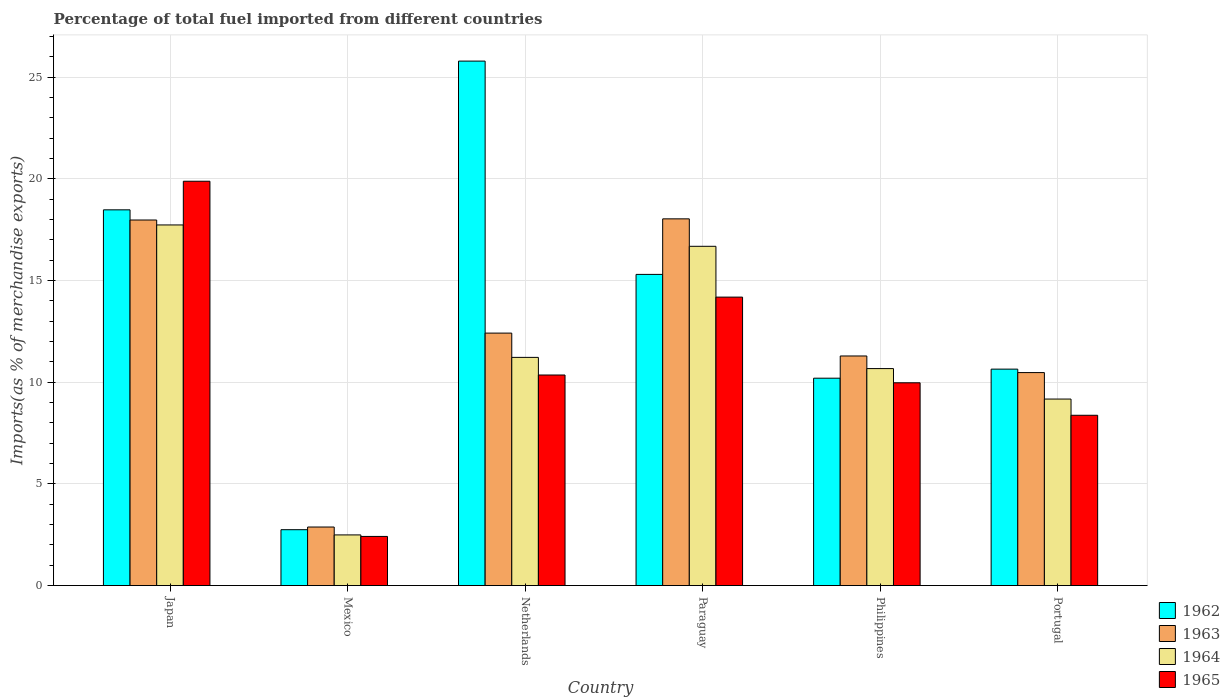How many different coloured bars are there?
Give a very brief answer. 4. How many groups of bars are there?
Keep it short and to the point. 6. Are the number of bars per tick equal to the number of legend labels?
Provide a short and direct response. Yes. How many bars are there on the 3rd tick from the left?
Offer a terse response. 4. What is the label of the 4th group of bars from the left?
Offer a terse response. Paraguay. In how many cases, is the number of bars for a given country not equal to the number of legend labels?
Provide a succinct answer. 0. What is the percentage of imports to different countries in 1963 in Portugal?
Offer a terse response. 10.47. Across all countries, what is the maximum percentage of imports to different countries in 1962?
Make the answer very short. 25.79. Across all countries, what is the minimum percentage of imports to different countries in 1965?
Your answer should be compact. 2.42. In which country was the percentage of imports to different countries in 1965 minimum?
Your answer should be compact. Mexico. What is the total percentage of imports to different countries in 1964 in the graph?
Your answer should be very brief. 67.96. What is the difference between the percentage of imports to different countries in 1964 in Paraguay and that in Philippines?
Provide a succinct answer. 6.01. What is the difference between the percentage of imports to different countries in 1964 in Paraguay and the percentage of imports to different countries in 1963 in Netherlands?
Make the answer very short. 4.27. What is the average percentage of imports to different countries in 1965 per country?
Keep it short and to the point. 10.86. What is the difference between the percentage of imports to different countries of/in 1964 and percentage of imports to different countries of/in 1965 in Philippines?
Your answer should be compact. 0.7. What is the ratio of the percentage of imports to different countries in 1963 in Mexico to that in Netherlands?
Make the answer very short. 0.23. Is the difference between the percentage of imports to different countries in 1964 in Paraguay and Philippines greater than the difference between the percentage of imports to different countries in 1965 in Paraguay and Philippines?
Offer a terse response. Yes. What is the difference between the highest and the second highest percentage of imports to different countries in 1963?
Offer a very short reply. -0.06. What is the difference between the highest and the lowest percentage of imports to different countries in 1965?
Ensure brevity in your answer.  17.46. Is the sum of the percentage of imports to different countries in 1965 in Japan and Paraguay greater than the maximum percentage of imports to different countries in 1962 across all countries?
Provide a succinct answer. Yes. Is it the case that in every country, the sum of the percentage of imports to different countries in 1962 and percentage of imports to different countries in 1965 is greater than the sum of percentage of imports to different countries in 1964 and percentage of imports to different countries in 1963?
Provide a succinct answer. No. What does the 4th bar from the left in Philippines represents?
Offer a very short reply. 1965. What does the 4th bar from the right in Netherlands represents?
Your response must be concise. 1962. Are all the bars in the graph horizontal?
Offer a terse response. No. Does the graph contain any zero values?
Ensure brevity in your answer.  No. Does the graph contain grids?
Give a very brief answer. Yes. How many legend labels are there?
Your response must be concise. 4. What is the title of the graph?
Make the answer very short. Percentage of total fuel imported from different countries. Does "1978" appear as one of the legend labels in the graph?
Provide a short and direct response. No. What is the label or title of the X-axis?
Provide a succinct answer. Country. What is the label or title of the Y-axis?
Provide a succinct answer. Imports(as % of merchandise exports). What is the Imports(as % of merchandise exports) in 1962 in Japan?
Ensure brevity in your answer.  18.47. What is the Imports(as % of merchandise exports) of 1963 in Japan?
Your answer should be compact. 17.97. What is the Imports(as % of merchandise exports) of 1964 in Japan?
Your answer should be very brief. 17.73. What is the Imports(as % of merchandise exports) in 1965 in Japan?
Provide a succinct answer. 19.88. What is the Imports(as % of merchandise exports) in 1962 in Mexico?
Provide a short and direct response. 2.75. What is the Imports(as % of merchandise exports) in 1963 in Mexico?
Provide a succinct answer. 2.88. What is the Imports(as % of merchandise exports) of 1964 in Mexico?
Your answer should be compact. 2.49. What is the Imports(as % of merchandise exports) of 1965 in Mexico?
Ensure brevity in your answer.  2.42. What is the Imports(as % of merchandise exports) of 1962 in Netherlands?
Keep it short and to the point. 25.79. What is the Imports(as % of merchandise exports) of 1963 in Netherlands?
Your answer should be compact. 12.41. What is the Imports(as % of merchandise exports) of 1964 in Netherlands?
Your answer should be compact. 11.22. What is the Imports(as % of merchandise exports) in 1965 in Netherlands?
Ensure brevity in your answer.  10.35. What is the Imports(as % of merchandise exports) in 1962 in Paraguay?
Provide a short and direct response. 15.3. What is the Imports(as % of merchandise exports) in 1963 in Paraguay?
Your answer should be compact. 18.03. What is the Imports(as % of merchandise exports) in 1964 in Paraguay?
Ensure brevity in your answer.  16.68. What is the Imports(as % of merchandise exports) of 1965 in Paraguay?
Keep it short and to the point. 14.18. What is the Imports(as % of merchandise exports) of 1962 in Philippines?
Ensure brevity in your answer.  10.2. What is the Imports(as % of merchandise exports) in 1963 in Philippines?
Your answer should be compact. 11.29. What is the Imports(as % of merchandise exports) of 1964 in Philippines?
Your response must be concise. 10.67. What is the Imports(as % of merchandise exports) of 1965 in Philippines?
Your answer should be compact. 9.97. What is the Imports(as % of merchandise exports) of 1962 in Portugal?
Your response must be concise. 10.64. What is the Imports(as % of merchandise exports) in 1963 in Portugal?
Offer a terse response. 10.47. What is the Imports(as % of merchandise exports) of 1964 in Portugal?
Provide a short and direct response. 9.17. What is the Imports(as % of merchandise exports) of 1965 in Portugal?
Give a very brief answer. 8.37. Across all countries, what is the maximum Imports(as % of merchandise exports) of 1962?
Offer a very short reply. 25.79. Across all countries, what is the maximum Imports(as % of merchandise exports) of 1963?
Provide a short and direct response. 18.03. Across all countries, what is the maximum Imports(as % of merchandise exports) in 1964?
Make the answer very short. 17.73. Across all countries, what is the maximum Imports(as % of merchandise exports) in 1965?
Offer a very short reply. 19.88. Across all countries, what is the minimum Imports(as % of merchandise exports) of 1962?
Offer a very short reply. 2.75. Across all countries, what is the minimum Imports(as % of merchandise exports) in 1963?
Ensure brevity in your answer.  2.88. Across all countries, what is the minimum Imports(as % of merchandise exports) in 1964?
Keep it short and to the point. 2.49. Across all countries, what is the minimum Imports(as % of merchandise exports) in 1965?
Offer a very short reply. 2.42. What is the total Imports(as % of merchandise exports) in 1962 in the graph?
Provide a short and direct response. 83.15. What is the total Imports(as % of merchandise exports) of 1963 in the graph?
Offer a terse response. 73.06. What is the total Imports(as % of merchandise exports) in 1964 in the graph?
Keep it short and to the point. 67.96. What is the total Imports(as % of merchandise exports) in 1965 in the graph?
Keep it short and to the point. 65.17. What is the difference between the Imports(as % of merchandise exports) of 1962 in Japan and that in Mexico?
Make the answer very short. 15.73. What is the difference between the Imports(as % of merchandise exports) in 1963 in Japan and that in Mexico?
Ensure brevity in your answer.  15.1. What is the difference between the Imports(as % of merchandise exports) of 1964 in Japan and that in Mexico?
Your answer should be very brief. 15.24. What is the difference between the Imports(as % of merchandise exports) of 1965 in Japan and that in Mexico?
Ensure brevity in your answer.  17.46. What is the difference between the Imports(as % of merchandise exports) in 1962 in Japan and that in Netherlands?
Your answer should be compact. -7.31. What is the difference between the Imports(as % of merchandise exports) of 1963 in Japan and that in Netherlands?
Make the answer very short. 5.56. What is the difference between the Imports(as % of merchandise exports) in 1964 in Japan and that in Netherlands?
Give a very brief answer. 6.51. What is the difference between the Imports(as % of merchandise exports) of 1965 in Japan and that in Netherlands?
Provide a succinct answer. 9.53. What is the difference between the Imports(as % of merchandise exports) of 1962 in Japan and that in Paraguay?
Make the answer very short. 3.17. What is the difference between the Imports(as % of merchandise exports) in 1963 in Japan and that in Paraguay?
Your answer should be compact. -0.06. What is the difference between the Imports(as % of merchandise exports) in 1964 in Japan and that in Paraguay?
Provide a succinct answer. 1.05. What is the difference between the Imports(as % of merchandise exports) of 1965 in Japan and that in Paraguay?
Your answer should be very brief. 5.7. What is the difference between the Imports(as % of merchandise exports) of 1962 in Japan and that in Philippines?
Offer a very short reply. 8.28. What is the difference between the Imports(as % of merchandise exports) of 1963 in Japan and that in Philippines?
Provide a succinct answer. 6.69. What is the difference between the Imports(as % of merchandise exports) of 1964 in Japan and that in Philippines?
Provide a succinct answer. 7.06. What is the difference between the Imports(as % of merchandise exports) of 1965 in Japan and that in Philippines?
Make the answer very short. 9.91. What is the difference between the Imports(as % of merchandise exports) in 1962 in Japan and that in Portugal?
Give a very brief answer. 7.83. What is the difference between the Imports(as % of merchandise exports) of 1963 in Japan and that in Portugal?
Keep it short and to the point. 7.5. What is the difference between the Imports(as % of merchandise exports) of 1964 in Japan and that in Portugal?
Provide a short and direct response. 8.56. What is the difference between the Imports(as % of merchandise exports) in 1965 in Japan and that in Portugal?
Ensure brevity in your answer.  11.51. What is the difference between the Imports(as % of merchandise exports) of 1962 in Mexico and that in Netherlands?
Your answer should be compact. -23.04. What is the difference between the Imports(as % of merchandise exports) of 1963 in Mexico and that in Netherlands?
Your answer should be compact. -9.53. What is the difference between the Imports(as % of merchandise exports) of 1964 in Mexico and that in Netherlands?
Provide a short and direct response. -8.73. What is the difference between the Imports(as % of merchandise exports) in 1965 in Mexico and that in Netherlands?
Offer a very short reply. -7.94. What is the difference between the Imports(as % of merchandise exports) in 1962 in Mexico and that in Paraguay?
Make the answer very short. -12.55. What is the difference between the Imports(as % of merchandise exports) of 1963 in Mexico and that in Paraguay?
Make the answer very short. -15.15. What is the difference between the Imports(as % of merchandise exports) in 1964 in Mexico and that in Paraguay?
Ensure brevity in your answer.  -14.19. What is the difference between the Imports(as % of merchandise exports) of 1965 in Mexico and that in Paraguay?
Provide a short and direct response. -11.77. What is the difference between the Imports(as % of merchandise exports) in 1962 in Mexico and that in Philippines?
Give a very brief answer. -7.45. What is the difference between the Imports(as % of merchandise exports) in 1963 in Mexico and that in Philippines?
Offer a very short reply. -8.41. What is the difference between the Imports(as % of merchandise exports) in 1964 in Mexico and that in Philippines?
Offer a terse response. -8.18. What is the difference between the Imports(as % of merchandise exports) of 1965 in Mexico and that in Philippines?
Give a very brief answer. -7.55. What is the difference between the Imports(as % of merchandise exports) in 1962 in Mexico and that in Portugal?
Offer a very short reply. -7.89. What is the difference between the Imports(as % of merchandise exports) of 1963 in Mexico and that in Portugal?
Your answer should be compact. -7.59. What is the difference between the Imports(as % of merchandise exports) of 1964 in Mexico and that in Portugal?
Make the answer very short. -6.68. What is the difference between the Imports(as % of merchandise exports) in 1965 in Mexico and that in Portugal?
Your answer should be compact. -5.96. What is the difference between the Imports(as % of merchandise exports) of 1962 in Netherlands and that in Paraguay?
Offer a terse response. 10.49. What is the difference between the Imports(as % of merchandise exports) in 1963 in Netherlands and that in Paraguay?
Make the answer very short. -5.62. What is the difference between the Imports(as % of merchandise exports) of 1964 in Netherlands and that in Paraguay?
Ensure brevity in your answer.  -5.46. What is the difference between the Imports(as % of merchandise exports) in 1965 in Netherlands and that in Paraguay?
Make the answer very short. -3.83. What is the difference between the Imports(as % of merchandise exports) in 1962 in Netherlands and that in Philippines?
Provide a short and direct response. 15.59. What is the difference between the Imports(as % of merchandise exports) of 1963 in Netherlands and that in Philippines?
Ensure brevity in your answer.  1.12. What is the difference between the Imports(as % of merchandise exports) in 1964 in Netherlands and that in Philippines?
Offer a terse response. 0.55. What is the difference between the Imports(as % of merchandise exports) in 1965 in Netherlands and that in Philippines?
Keep it short and to the point. 0.38. What is the difference between the Imports(as % of merchandise exports) in 1962 in Netherlands and that in Portugal?
Offer a very short reply. 15.15. What is the difference between the Imports(as % of merchandise exports) of 1963 in Netherlands and that in Portugal?
Offer a very short reply. 1.94. What is the difference between the Imports(as % of merchandise exports) in 1964 in Netherlands and that in Portugal?
Make the answer very short. 2.05. What is the difference between the Imports(as % of merchandise exports) in 1965 in Netherlands and that in Portugal?
Your response must be concise. 1.98. What is the difference between the Imports(as % of merchandise exports) of 1962 in Paraguay and that in Philippines?
Provide a short and direct response. 5.1. What is the difference between the Imports(as % of merchandise exports) in 1963 in Paraguay and that in Philippines?
Your answer should be compact. 6.74. What is the difference between the Imports(as % of merchandise exports) of 1964 in Paraguay and that in Philippines?
Make the answer very short. 6.01. What is the difference between the Imports(as % of merchandise exports) of 1965 in Paraguay and that in Philippines?
Offer a very short reply. 4.21. What is the difference between the Imports(as % of merchandise exports) in 1962 in Paraguay and that in Portugal?
Offer a terse response. 4.66. What is the difference between the Imports(as % of merchandise exports) of 1963 in Paraguay and that in Portugal?
Your answer should be very brief. 7.56. What is the difference between the Imports(as % of merchandise exports) of 1964 in Paraguay and that in Portugal?
Offer a very short reply. 7.51. What is the difference between the Imports(as % of merchandise exports) of 1965 in Paraguay and that in Portugal?
Provide a succinct answer. 5.81. What is the difference between the Imports(as % of merchandise exports) in 1962 in Philippines and that in Portugal?
Provide a succinct answer. -0.45. What is the difference between the Imports(as % of merchandise exports) in 1963 in Philippines and that in Portugal?
Offer a terse response. 0.82. What is the difference between the Imports(as % of merchandise exports) of 1964 in Philippines and that in Portugal?
Keep it short and to the point. 1.5. What is the difference between the Imports(as % of merchandise exports) of 1965 in Philippines and that in Portugal?
Offer a very short reply. 1.6. What is the difference between the Imports(as % of merchandise exports) of 1962 in Japan and the Imports(as % of merchandise exports) of 1963 in Mexico?
Your response must be concise. 15.6. What is the difference between the Imports(as % of merchandise exports) of 1962 in Japan and the Imports(as % of merchandise exports) of 1964 in Mexico?
Give a very brief answer. 15.98. What is the difference between the Imports(as % of merchandise exports) in 1962 in Japan and the Imports(as % of merchandise exports) in 1965 in Mexico?
Provide a succinct answer. 16.06. What is the difference between the Imports(as % of merchandise exports) of 1963 in Japan and the Imports(as % of merchandise exports) of 1964 in Mexico?
Provide a short and direct response. 15.48. What is the difference between the Imports(as % of merchandise exports) of 1963 in Japan and the Imports(as % of merchandise exports) of 1965 in Mexico?
Give a very brief answer. 15.56. What is the difference between the Imports(as % of merchandise exports) of 1964 in Japan and the Imports(as % of merchandise exports) of 1965 in Mexico?
Your answer should be compact. 15.32. What is the difference between the Imports(as % of merchandise exports) in 1962 in Japan and the Imports(as % of merchandise exports) in 1963 in Netherlands?
Your answer should be compact. 6.06. What is the difference between the Imports(as % of merchandise exports) of 1962 in Japan and the Imports(as % of merchandise exports) of 1964 in Netherlands?
Offer a very short reply. 7.25. What is the difference between the Imports(as % of merchandise exports) of 1962 in Japan and the Imports(as % of merchandise exports) of 1965 in Netherlands?
Your response must be concise. 8.12. What is the difference between the Imports(as % of merchandise exports) of 1963 in Japan and the Imports(as % of merchandise exports) of 1964 in Netherlands?
Ensure brevity in your answer.  6.76. What is the difference between the Imports(as % of merchandise exports) in 1963 in Japan and the Imports(as % of merchandise exports) in 1965 in Netherlands?
Offer a very short reply. 7.62. What is the difference between the Imports(as % of merchandise exports) in 1964 in Japan and the Imports(as % of merchandise exports) in 1965 in Netherlands?
Make the answer very short. 7.38. What is the difference between the Imports(as % of merchandise exports) in 1962 in Japan and the Imports(as % of merchandise exports) in 1963 in Paraguay?
Your answer should be compact. 0.44. What is the difference between the Imports(as % of merchandise exports) of 1962 in Japan and the Imports(as % of merchandise exports) of 1964 in Paraguay?
Provide a succinct answer. 1.79. What is the difference between the Imports(as % of merchandise exports) of 1962 in Japan and the Imports(as % of merchandise exports) of 1965 in Paraguay?
Your response must be concise. 4.29. What is the difference between the Imports(as % of merchandise exports) of 1963 in Japan and the Imports(as % of merchandise exports) of 1964 in Paraguay?
Offer a very short reply. 1.29. What is the difference between the Imports(as % of merchandise exports) of 1963 in Japan and the Imports(as % of merchandise exports) of 1965 in Paraguay?
Give a very brief answer. 3.79. What is the difference between the Imports(as % of merchandise exports) in 1964 in Japan and the Imports(as % of merchandise exports) in 1965 in Paraguay?
Your answer should be very brief. 3.55. What is the difference between the Imports(as % of merchandise exports) of 1962 in Japan and the Imports(as % of merchandise exports) of 1963 in Philippines?
Give a very brief answer. 7.19. What is the difference between the Imports(as % of merchandise exports) of 1962 in Japan and the Imports(as % of merchandise exports) of 1964 in Philippines?
Offer a very short reply. 7.81. What is the difference between the Imports(as % of merchandise exports) in 1962 in Japan and the Imports(as % of merchandise exports) in 1965 in Philippines?
Keep it short and to the point. 8.5. What is the difference between the Imports(as % of merchandise exports) of 1963 in Japan and the Imports(as % of merchandise exports) of 1964 in Philippines?
Ensure brevity in your answer.  7.31. What is the difference between the Imports(as % of merchandise exports) of 1963 in Japan and the Imports(as % of merchandise exports) of 1965 in Philippines?
Make the answer very short. 8. What is the difference between the Imports(as % of merchandise exports) of 1964 in Japan and the Imports(as % of merchandise exports) of 1965 in Philippines?
Provide a short and direct response. 7.76. What is the difference between the Imports(as % of merchandise exports) in 1962 in Japan and the Imports(as % of merchandise exports) in 1963 in Portugal?
Make the answer very short. 8. What is the difference between the Imports(as % of merchandise exports) of 1962 in Japan and the Imports(as % of merchandise exports) of 1964 in Portugal?
Offer a terse response. 9.3. What is the difference between the Imports(as % of merchandise exports) of 1962 in Japan and the Imports(as % of merchandise exports) of 1965 in Portugal?
Provide a succinct answer. 10.1. What is the difference between the Imports(as % of merchandise exports) in 1963 in Japan and the Imports(as % of merchandise exports) in 1964 in Portugal?
Keep it short and to the point. 8.8. What is the difference between the Imports(as % of merchandise exports) in 1963 in Japan and the Imports(as % of merchandise exports) in 1965 in Portugal?
Keep it short and to the point. 9.6. What is the difference between the Imports(as % of merchandise exports) of 1964 in Japan and the Imports(as % of merchandise exports) of 1965 in Portugal?
Provide a short and direct response. 9.36. What is the difference between the Imports(as % of merchandise exports) in 1962 in Mexico and the Imports(as % of merchandise exports) in 1963 in Netherlands?
Provide a succinct answer. -9.67. What is the difference between the Imports(as % of merchandise exports) of 1962 in Mexico and the Imports(as % of merchandise exports) of 1964 in Netherlands?
Give a very brief answer. -8.47. What is the difference between the Imports(as % of merchandise exports) in 1962 in Mexico and the Imports(as % of merchandise exports) in 1965 in Netherlands?
Keep it short and to the point. -7.61. What is the difference between the Imports(as % of merchandise exports) in 1963 in Mexico and the Imports(as % of merchandise exports) in 1964 in Netherlands?
Provide a short and direct response. -8.34. What is the difference between the Imports(as % of merchandise exports) in 1963 in Mexico and the Imports(as % of merchandise exports) in 1965 in Netherlands?
Your response must be concise. -7.47. What is the difference between the Imports(as % of merchandise exports) in 1964 in Mexico and the Imports(as % of merchandise exports) in 1965 in Netherlands?
Make the answer very short. -7.86. What is the difference between the Imports(as % of merchandise exports) in 1962 in Mexico and the Imports(as % of merchandise exports) in 1963 in Paraguay?
Provide a succinct answer. -15.28. What is the difference between the Imports(as % of merchandise exports) in 1962 in Mexico and the Imports(as % of merchandise exports) in 1964 in Paraguay?
Provide a succinct answer. -13.93. What is the difference between the Imports(as % of merchandise exports) of 1962 in Mexico and the Imports(as % of merchandise exports) of 1965 in Paraguay?
Your answer should be very brief. -11.44. What is the difference between the Imports(as % of merchandise exports) in 1963 in Mexico and the Imports(as % of merchandise exports) in 1964 in Paraguay?
Offer a terse response. -13.8. What is the difference between the Imports(as % of merchandise exports) in 1963 in Mexico and the Imports(as % of merchandise exports) in 1965 in Paraguay?
Make the answer very short. -11.3. What is the difference between the Imports(as % of merchandise exports) of 1964 in Mexico and the Imports(as % of merchandise exports) of 1965 in Paraguay?
Keep it short and to the point. -11.69. What is the difference between the Imports(as % of merchandise exports) in 1962 in Mexico and the Imports(as % of merchandise exports) in 1963 in Philippines?
Make the answer very short. -8.54. What is the difference between the Imports(as % of merchandise exports) in 1962 in Mexico and the Imports(as % of merchandise exports) in 1964 in Philippines?
Ensure brevity in your answer.  -7.92. What is the difference between the Imports(as % of merchandise exports) in 1962 in Mexico and the Imports(as % of merchandise exports) in 1965 in Philippines?
Your answer should be very brief. -7.22. What is the difference between the Imports(as % of merchandise exports) in 1963 in Mexico and the Imports(as % of merchandise exports) in 1964 in Philippines?
Provide a short and direct response. -7.79. What is the difference between the Imports(as % of merchandise exports) in 1963 in Mexico and the Imports(as % of merchandise exports) in 1965 in Philippines?
Give a very brief answer. -7.09. What is the difference between the Imports(as % of merchandise exports) of 1964 in Mexico and the Imports(as % of merchandise exports) of 1965 in Philippines?
Provide a short and direct response. -7.48. What is the difference between the Imports(as % of merchandise exports) of 1962 in Mexico and the Imports(as % of merchandise exports) of 1963 in Portugal?
Make the answer very short. -7.73. What is the difference between the Imports(as % of merchandise exports) in 1962 in Mexico and the Imports(as % of merchandise exports) in 1964 in Portugal?
Keep it short and to the point. -6.42. What is the difference between the Imports(as % of merchandise exports) of 1962 in Mexico and the Imports(as % of merchandise exports) of 1965 in Portugal?
Offer a very short reply. -5.63. What is the difference between the Imports(as % of merchandise exports) in 1963 in Mexico and the Imports(as % of merchandise exports) in 1964 in Portugal?
Keep it short and to the point. -6.29. What is the difference between the Imports(as % of merchandise exports) in 1963 in Mexico and the Imports(as % of merchandise exports) in 1965 in Portugal?
Give a very brief answer. -5.49. What is the difference between the Imports(as % of merchandise exports) in 1964 in Mexico and the Imports(as % of merchandise exports) in 1965 in Portugal?
Offer a terse response. -5.88. What is the difference between the Imports(as % of merchandise exports) of 1962 in Netherlands and the Imports(as % of merchandise exports) of 1963 in Paraguay?
Give a very brief answer. 7.76. What is the difference between the Imports(as % of merchandise exports) in 1962 in Netherlands and the Imports(as % of merchandise exports) in 1964 in Paraguay?
Keep it short and to the point. 9.11. What is the difference between the Imports(as % of merchandise exports) of 1962 in Netherlands and the Imports(as % of merchandise exports) of 1965 in Paraguay?
Your answer should be compact. 11.6. What is the difference between the Imports(as % of merchandise exports) in 1963 in Netherlands and the Imports(as % of merchandise exports) in 1964 in Paraguay?
Ensure brevity in your answer.  -4.27. What is the difference between the Imports(as % of merchandise exports) in 1963 in Netherlands and the Imports(as % of merchandise exports) in 1965 in Paraguay?
Provide a short and direct response. -1.77. What is the difference between the Imports(as % of merchandise exports) in 1964 in Netherlands and the Imports(as % of merchandise exports) in 1965 in Paraguay?
Give a very brief answer. -2.96. What is the difference between the Imports(as % of merchandise exports) of 1962 in Netherlands and the Imports(as % of merchandise exports) of 1963 in Philippines?
Give a very brief answer. 14.5. What is the difference between the Imports(as % of merchandise exports) of 1962 in Netherlands and the Imports(as % of merchandise exports) of 1964 in Philippines?
Your answer should be very brief. 15.12. What is the difference between the Imports(as % of merchandise exports) in 1962 in Netherlands and the Imports(as % of merchandise exports) in 1965 in Philippines?
Provide a succinct answer. 15.82. What is the difference between the Imports(as % of merchandise exports) of 1963 in Netherlands and the Imports(as % of merchandise exports) of 1964 in Philippines?
Provide a succinct answer. 1.74. What is the difference between the Imports(as % of merchandise exports) in 1963 in Netherlands and the Imports(as % of merchandise exports) in 1965 in Philippines?
Your answer should be compact. 2.44. What is the difference between the Imports(as % of merchandise exports) in 1964 in Netherlands and the Imports(as % of merchandise exports) in 1965 in Philippines?
Provide a short and direct response. 1.25. What is the difference between the Imports(as % of merchandise exports) of 1962 in Netherlands and the Imports(as % of merchandise exports) of 1963 in Portugal?
Ensure brevity in your answer.  15.32. What is the difference between the Imports(as % of merchandise exports) of 1962 in Netherlands and the Imports(as % of merchandise exports) of 1964 in Portugal?
Provide a short and direct response. 16.62. What is the difference between the Imports(as % of merchandise exports) of 1962 in Netherlands and the Imports(as % of merchandise exports) of 1965 in Portugal?
Give a very brief answer. 17.41. What is the difference between the Imports(as % of merchandise exports) in 1963 in Netherlands and the Imports(as % of merchandise exports) in 1964 in Portugal?
Offer a terse response. 3.24. What is the difference between the Imports(as % of merchandise exports) of 1963 in Netherlands and the Imports(as % of merchandise exports) of 1965 in Portugal?
Your answer should be compact. 4.04. What is the difference between the Imports(as % of merchandise exports) in 1964 in Netherlands and the Imports(as % of merchandise exports) in 1965 in Portugal?
Provide a succinct answer. 2.85. What is the difference between the Imports(as % of merchandise exports) in 1962 in Paraguay and the Imports(as % of merchandise exports) in 1963 in Philippines?
Provide a succinct answer. 4.01. What is the difference between the Imports(as % of merchandise exports) in 1962 in Paraguay and the Imports(as % of merchandise exports) in 1964 in Philippines?
Your answer should be very brief. 4.63. What is the difference between the Imports(as % of merchandise exports) in 1962 in Paraguay and the Imports(as % of merchandise exports) in 1965 in Philippines?
Offer a very short reply. 5.33. What is the difference between the Imports(as % of merchandise exports) in 1963 in Paraguay and the Imports(as % of merchandise exports) in 1964 in Philippines?
Keep it short and to the point. 7.36. What is the difference between the Imports(as % of merchandise exports) in 1963 in Paraguay and the Imports(as % of merchandise exports) in 1965 in Philippines?
Offer a very short reply. 8.06. What is the difference between the Imports(as % of merchandise exports) in 1964 in Paraguay and the Imports(as % of merchandise exports) in 1965 in Philippines?
Give a very brief answer. 6.71. What is the difference between the Imports(as % of merchandise exports) of 1962 in Paraguay and the Imports(as % of merchandise exports) of 1963 in Portugal?
Give a very brief answer. 4.83. What is the difference between the Imports(as % of merchandise exports) in 1962 in Paraguay and the Imports(as % of merchandise exports) in 1964 in Portugal?
Your response must be concise. 6.13. What is the difference between the Imports(as % of merchandise exports) of 1962 in Paraguay and the Imports(as % of merchandise exports) of 1965 in Portugal?
Provide a succinct answer. 6.93. What is the difference between the Imports(as % of merchandise exports) of 1963 in Paraguay and the Imports(as % of merchandise exports) of 1964 in Portugal?
Your response must be concise. 8.86. What is the difference between the Imports(as % of merchandise exports) of 1963 in Paraguay and the Imports(as % of merchandise exports) of 1965 in Portugal?
Offer a terse response. 9.66. What is the difference between the Imports(as % of merchandise exports) of 1964 in Paraguay and the Imports(as % of merchandise exports) of 1965 in Portugal?
Your answer should be very brief. 8.31. What is the difference between the Imports(as % of merchandise exports) in 1962 in Philippines and the Imports(as % of merchandise exports) in 1963 in Portugal?
Your answer should be very brief. -0.28. What is the difference between the Imports(as % of merchandise exports) in 1962 in Philippines and the Imports(as % of merchandise exports) in 1964 in Portugal?
Keep it short and to the point. 1.03. What is the difference between the Imports(as % of merchandise exports) in 1962 in Philippines and the Imports(as % of merchandise exports) in 1965 in Portugal?
Your response must be concise. 1.82. What is the difference between the Imports(as % of merchandise exports) in 1963 in Philippines and the Imports(as % of merchandise exports) in 1964 in Portugal?
Your response must be concise. 2.12. What is the difference between the Imports(as % of merchandise exports) of 1963 in Philippines and the Imports(as % of merchandise exports) of 1965 in Portugal?
Your answer should be compact. 2.92. What is the difference between the Imports(as % of merchandise exports) of 1964 in Philippines and the Imports(as % of merchandise exports) of 1965 in Portugal?
Provide a succinct answer. 2.3. What is the average Imports(as % of merchandise exports) in 1962 per country?
Make the answer very short. 13.86. What is the average Imports(as % of merchandise exports) of 1963 per country?
Offer a terse response. 12.18. What is the average Imports(as % of merchandise exports) of 1964 per country?
Provide a short and direct response. 11.33. What is the average Imports(as % of merchandise exports) of 1965 per country?
Make the answer very short. 10.86. What is the difference between the Imports(as % of merchandise exports) of 1962 and Imports(as % of merchandise exports) of 1963 in Japan?
Provide a short and direct response. 0.5. What is the difference between the Imports(as % of merchandise exports) in 1962 and Imports(as % of merchandise exports) in 1964 in Japan?
Offer a very short reply. 0.74. What is the difference between the Imports(as % of merchandise exports) in 1962 and Imports(as % of merchandise exports) in 1965 in Japan?
Keep it short and to the point. -1.41. What is the difference between the Imports(as % of merchandise exports) in 1963 and Imports(as % of merchandise exports) in 1964 in Japan?
Keep it short and to the point. 0.24. What is the difference between the Imports(as % of merchandise exports) in 1963 and Imports(as % of merchandise exports) in 1965 in Japan?
Give a very brief answer. -1.91. What is the difference between the Imports(as % of merchandise exports) of 1964 and Imports(as % of merchandise exports) of 1965 in Japan?
Give a very brief answer. -2.15. What is the difference between the Imports(as % of merchandise exports) in 1962 and Imports(as % of merchandise exports) in 1963 in Mexico?
Give a very brief answer. -0.13. What is the difference between the Imports(as % of merchandise exports) of 1962 and Imports(as % of merchandise exports) of 1964 in Mexico?
Your response must be concise. 0.26. What is the difference between the Imports(as % of merchandise exports) in 1962 and Imports(as % of merchandise exports) in 1965 in Mexico?
Your answer should be compact. 0.33. What is the difference between the Imports(as % of merchandise exports) of 1963 and Imports(as % of merchandise exports) of 1964 in Mexico?
Make the answer very short. 0.39. What is the difference between the Imports(as % of merchandise exports) of 1963 and Imports(as % of merchandise exports) of 1965 in Mexico?
Make the answer very short. 0.46. What is the difference between the Imports(as % of merchandise exports) in 1964 and Imports(as % of merchandise exports) in 1965 in Mexico?
Offer a very short reply. 0.07. What is the difference between the Imports(as % of merchandise exports) in 1962 and Imports(as % of merchandise exports) in 1963 in Netherlands?
Your answer should be compact. 13.37. What is the difference between the Imports(as % of merchandise exports) of 1962 and Imports(as % of merchandise exports) of 1964 in Netherlands?
Make the answer very short. 14.57. What is the difference between the Imports(as % of merchandise exports) of 1962 and Imports(as % of merchandise exports) of 1965 in Netherlands?
Ensure brevity in your answer.  15.43. What is the difference between the Imports(as % of merchandise exports) of 1963 and Imports(as % of merchandise exports) of 1964 in Netherlands?
Provide a short and direct response. 1.19. What is the difference between the Imports(as % of merchandise exports) in 1963 and Imports(as % of merchandise exports) in 1965 in Netherlands?
Give a very brief answer. 2.06. What is the difference between the Imports(as % of merchandise exports) in 1964 and Imports(as % of merchandise exports) in 1965 in Netherlands?
Provide a short and direct response. 0.87. What is the difference between the Imports(as % of merchandise exports) in 1962 and Imports(as % of merchandise exports) in 1963 in Paraguay?
Your answer should be very brief. -2.73. What is the difference between the Imports(as % of merchandise exports) in 1962 and Imports(as % of merchandise exports) in 1964 in Paraguay?
Make the answer very short. -1.38. What is the difference between the Imports(as % of merchandise exports) in 1962 and Imports(as % of merchandise exports) in 1965 in Paraguay?
Make the answer very short. 1.12. What is the difference between the Imports(as % of merchandise exports) of 1963 and Imports(as % of merchandise exports) of 1964 in Paraguay?
Your answer should be compact. 1.35. What is the difference between the Imports(as % of merchandise exports) of 1963 and Imports(as % of merchandise exports) of 1965 in Paraguay?
Make the answer very short. 3.85. What is the difference between the Imports(as % of merchandise exports) of 1964 and Imports(as % of merchandise exports) of 1965 in Paraguay?
Provide a short and direct response. 2.5. What is the difference between the Imports(as % of merchandise exports) of 1962 and Imports(as % of merchandise exports) of 1963 in Philippines?
Provide a succinct answer. -1.09. What is the difference between the Imports(as % of merchandise exports) of 1962 and Imports(as % of merchandise exports) of 1964 in Philippines?
Offer a terse response. -0.47. What is the difference between the Imports(as % of merchandise exports) of 1962 and Imports(as % of merchandise exports) of 1965 in Philippines?
Give a very brief answer. 0.23. What is the difference between the Imports(as % of merchandise exports) in 1963 and Imports(as % of merchandise exports) in 1964 in Philippines?
Keep it short and to the point. 0.62. What is the difference between the Imports(as % of merchandise exports) in 1963 and Imports(as % of merchandise exports) in 1965 in Philippines?
Give a very brief answer. 1.32. What is the difference between the Imports(as % of merchandise exports) in 1964 and Imports(as % of merchandise exports) in 1965 in Philippines?
Provide a short and direct response. 0.7. What is the difference between the Imports(as % of merchandise exports) in 1962 and Imports(as % of merchandise exports) in 1963 in Portugal?
Ensure brevity in your answer.  0.17. What is the difference between the Imports(as % of merchandise exports) in 1962 and Imports(as % of merchandise exports) in 1964 in Portugal?
Your answer should be very brief. 1.47. What is the difference between the Imports(as % of merchandise exports) in 1962 and Imports(as % of merchandise exports) in 1965 in Portugal?
Your answer should be very brief. 2.27. What is the difference between the Imports(as % of merchandise exports) in 1963 and Imports(as % of merchandise exports) in 1964 in Portugal?
Offer a very short reply. 1.3. What is the difference between the Imports(as % of merchandise exports) of 1963 and Imports(as % of merchandise exports) of 1965 in Portugal?
Give a very brief answer. 2.1. What is the difference between the Imports(as % of merchandise exports) in 1964 and Imports(as % of merchandise exports) in 1965 in Portugal?
Keep it short and to the point. 0.8. What is the ratio of the Imports(as % of merchandise exports) of 1962 in Japan to that in Mexico?
Make the answer very short. 6.72. What is the ratio of the Imports(as % of merchandise exports) of 1963 in Japan to that in Mexico?
Your answer should be compact. 6.24. What is the ratio of the Imports(as % of merchandise exports) of 1964 in Japan to that in Mexico?
Give a very brief answer. 7.12. What is the ratio of the Imports(as % of merchandise exports) of 1965 in Japan to that in Mexico?
Provide a short and direct response. 8.23. What is the ratio of the Imports(as % of merchandise exports) of 1962 in Japan to that in Netherlands?
Ensure brevity in your answer.  0.72. What is the ratio of the Imports(as % of merchandise exports) of 1963 in Japan to that in Netherlands?
Ensure brevity in your answer.  1.45. What is the ratio of the Imports(as % of merchandise exports) of 1964 in Japan to that in Netherlands?
Your answer should be compact. 1.58. What is the ratio of the Imports(as % of merchandise exports) of 1965 in Japan to that in Netherlands?
Your response must be concise. 1.92. What is the ratio of the Imports(as % of merchandise exports) in 1962 in Japan to that in Paraguay?
Keep it short and to the point. 1.21. What is the ratio of the Imports(as % of merchandise exports) of 1963 in Japan to that in Paraguay?
Give a very brief answer. 1. What is the ratio of the Imports(as % of merchandise exports) of 1964 in Japan to that in Paraguay?
Your response must be concise. 1.06. What is the ratio of the Imports(as % of merchandise exports) of 1965 in Japan to that in Paraguay?
Offer a terse response. 1.4. What is the ratio of the Imports(as % of merchandise exports) in 1962 in Japan to that in Philippines?
Give a very brief answer. 1.81. What is the ratio of the Imports(as % of merchandise exports) of 1963 in Japan to that in Philippines?
Provide a short and direct response. 1.59. What is the ratio of the Imports(as % of merchandise exports) in 1964 in Japan to that in Philippines?
Provide a short and direct response. 1.66. What is the ratio of the Imports(as % of merchandise exports) in 1965 in Japan to that in Philippines?
Provide a short and direct response. 1.99. What is the ratio of the Imports(as % of merchandise exports) of 1962 in Japan to that in Portugal?
Keep it short and to the point. 1.74. What is the ratio of the Imports(as % of merchandise exports) of 1963 in Japan to that in Portugal?
Your answer should be very brief. 1.72. What is the ratio of the Imports(as % of merchandise exports) in 1964 in Japan to that in Portugal?
Offer a very short reply. 1.93. What is the ratio of the Imports(as % of merchandise exports) of 1965 in Japan to that in Portugal?
Your answer should be compact. 2.37. What is the ratio of the Imports(as % of merchandise exports) of 1962 in Mexico to that in Netherlands?
Provide a succinct answer. 0.11. What is the ratio of the Imports(as % of merchandise exports) of 1963 in Mexico to that in Netherlands?
Your response must be concise. 0.23. What is the ratio of the Imports(as % of merchandise exports) of 1964 in Mexico to that in Netherlands?
Provide a succinct answer. 0.22. What is the ratio of the Imports(as % of merchandise exports) of 1965 in Mexico to that in Netherlands?
Give a very brief answer. 0.23. What is the ratio of the Imports(as % of merchandise exports) in 1962 in Mexico to that in Paraguay?
Make the answer very short. 0.18. What is the ratio of the Imports(as % of merchandise exports) of 1963 in Mexico to that in Paraguay?
Your answer should be very brief. 0.16. What is the ratio of the Imports(as % of merchandise exports) in 1964 in Mexico to that in Paraguay?
Provide a succinct answer. 0.15. What is the ratio of the Imports(as % of merchandise exports) in 1965 in Mexico to that in Paraguay?
Keep it short and to the point. 0.17. What is the ratio of the Imports(as % of merchandise exports) of 1962 in Mexico to that in Philippines?
Provide a short and direct response. 0.27. What is the ratio of the Imports(as % of merchandise exports) of 1963 in Mexico to that in Philippines?
Offer a very short reply. 0.26. What is the ratio of the Imports(as % of merchandise exports) in 1964 in Mexico to that in Philippines?
Offer a very short reply. 0.23. What is the ratio of the Imports(as % of merchandise exports) in 1965 in Mexico to that in Philippines?
Your response must be concise. 0.24. What is the ratio of the Imports(as % of merchandise exports) of 1962 in Mexico to that in Portugal?
Offer a very short reply. 0.26. What is the ratio of the Imports(as % of merchandise exports) of 1963 in Mexico to that in Portugal?
Ensure brevity in your answer.  0.27. What is the ratio of the Imports(as % of merchandise exports) in 1964 in Mexico to that in Portugal?
Make the answer very short. 0.27. What is the ratio of the Imports(as % of merchandise exports) of 1965 in Mexico to that in Portugal?
Offer a terse response. 0.29. What is the ratio of the Imports(as % of merchandise exports) in 1962 in Netherlands to that in Paraguay?
Offer a terse response. 1.69. What is the ratio of the Imports(as % of merchandise exports) of 1963 in Netherlands to that in Paraguay?
Your answer should be very brief. 0.69. What is the ratio of the Imports(as % of merchandise exports) in 1964 in Netherlands to that in Paraguay?
Offer a very short reply. 0.67. What is the ratio of the Imports(as % of merchandise exports) of 1965 in Netherlands to that in Paraguay?
Give a very brief answer. 0.73. What is the ratio of the Imports(as % of merchandise exports) of 1962 in Netherlands to that in Philippines?
Give a very brief answer. 2.53. What is the ratio of the Imports(as % of merchandise exports) of 1963 in Netherlands to that in Philippines?
Provide a short and direct response. 1.1. What is the ratio of the Imports(as % of merchandise exports) of 1964 in Netherlands to that in Philippines?
Keep it short and to the point. 1.05. What is the ratio of the Imports(as % of merchandise exports) of 1965 in Netherlands to that in Philippines?
Your answer should be very brief. 1.04. What is the ratio of the Imports(as % of merchandise exports) in 1962 in Netherlands to that in Portugal?
Provide a succinct answer. 2.42. What is the ratio of the Imports(as % of merchandise exports) in 1963 in Netherlands to that in Portugal?
Give a very brief answer. 1.19. What is the ratio of the Imports(as % of merchandise exports) of 1964 in Netherlands to that in Portugal?
Your response must be concise. 1.22. What is the ratio of the Imports(as % of merchandise exports) of 1965 in Netherlands to that in Portugal?
Offer a very short reply. 1.24. What is the ratio of the Imports(as % of merchandise exports) of 1962 in Paraguay to that in Philippines?
Your answer should be very brief. 1.5. What is the ratio of the Imports(as % of merchandise exports) of 1963 in Paraguay to that in Philippines?
Give a very brief answer. 1.6. What is the ratio of the Imports(as % of merchandise exports) of 1964 in Paraguay to that in Philippines?
Offer a terse response. 1.56. What is the ratio of the Imports(as % of merchandise exports) of 1965 in Paraguay to that in Philippines?
Offer a terse response. 1.42. What is the ratio of the Imports(as % of merchandise exports) in 1962 in Paraguay to that in Portugal?
Ensure brevity in your answer.  1.44. What is the ratio of the Imports(as % of merchandise exports) in 1963 in Paraguay to that in Portugal?
Make the answer very short. 1.72. What is the ratio of the Imports(as % of merchandise exports) of 1964 in Paraguay to that in Portugal?
Your response must be concise. 1.82. What is the ratio of the Imports(as % of merchandise exports) of 1965 in Paraguay to that in Portugal?
Your answer should be compact. 1.69. What is the ratio of the Imports(as % of merchandise exports) in 1962 in Philippines to that in Portugal?
Your answer should be very brief. 0.96. What is the ratio of the Imports(as % of merchandise exports) of 1963 in Philippines to that in Portugal?
Ensure brevity in your answer.  1.08. What is the ratio of the Imports(as % of merchandise exports) in 1964 in Philippines to that in Portugal?
Your response must be concise. 1.16. What is the ratio of the Imports(as % of merchandise exports) of 1965 in Philippines to that in Portugal?
Provide a succinct answer. 1.19. What is the difference between the highest and the second highest Imports(as % of merchandise exports) of 1962?
Offer a terse response. 7.31. What is the difference between the highest and the second highest Imports(as % of merchandise exports) in 1963?
Provide a succinct answer. 0.06. What is the difference between the highest and the second highest Imports(as % of merchandise exports) of 1964?
Offer a very short reply. 1.05. What is the difference between the highest and the second highest Imports(as % of merchandise exports) of 1965?
Provide a short and direct response. 5.7. What is the difference between the highest and the lowest Imports(as % of merchandise exports) of 1962?
Offer a very short reply. 23.04. What is the difference between the highest and the lowest Imports(as % of merchandise exports) of 1963?
Your answer should be very brief. 15.15. What is the difference between the highest and the lowest Imports(as % of merchandise exports) of 1964?
Keep it short and to the point. 15.24. What is the difference between the highest and the lowest Imports(as % of merchandise exports) in 1965?
Make the answer very short. 17.46. 